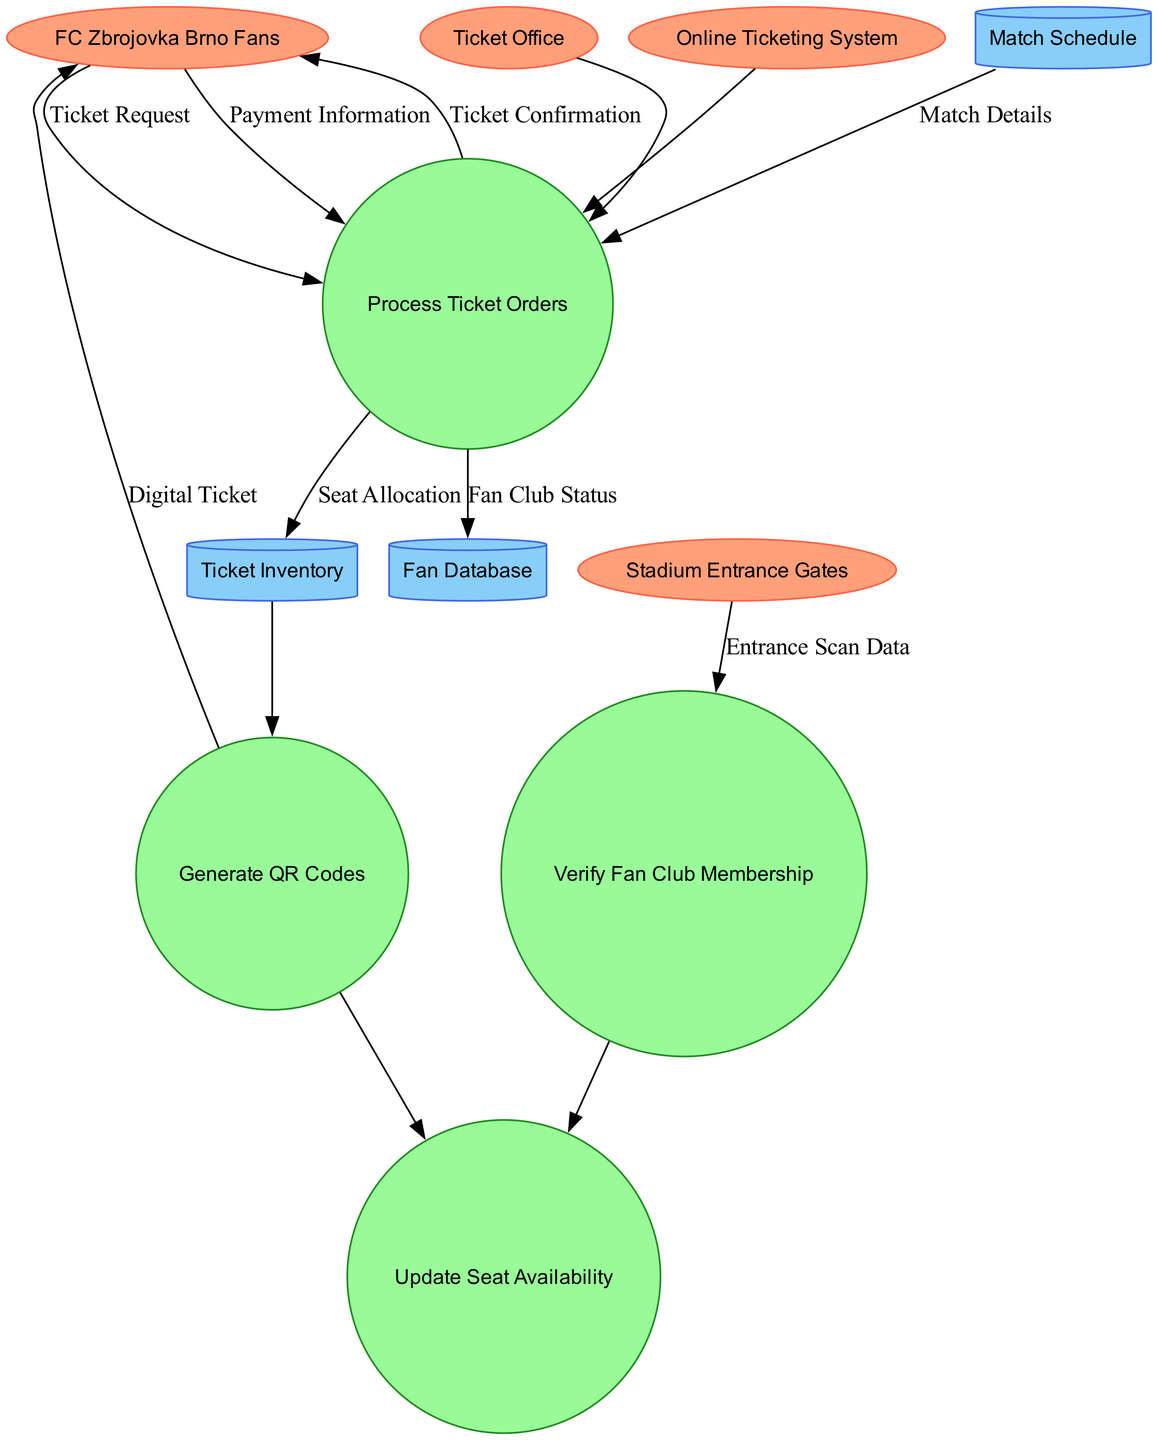What are the external entities present in the diagram? The external entities listed in the diagram are FC Zbrojovka Brno Fans, Ticket Office, Online Ticketing System, and Stadium Entrance Gates. These entities interact with the processes in the diagram.
Answer: FC Zbrojovka Brno Fans, Ticket Office, Online Ticketing System, Stadium Entrance Gates Which process generates QR Codes? The diagram indicates that the process responsible for generating QR Codes is labeled "Generate QR Codes." This can be directly identified in the processes section of the diagram.
Answer: Generate QR Codes How many data stores are depicted in the diagram? There are three data stores shown in the diagram, which are the Fan Database, Ticket Inventory, and Match Schedule. A count of the listed data stores confirms this.
Answer: 3 What type of data flow is established between FC Zbrojovka Brno Fans and the Match Schedule? According to the diagram, there is no direct data flow established between FC Zbrojovka Brno Fans and the Match Schedule. The flows indicate connections to processes rather than directly to this data store.
Answer: None What is the relationship between the "Process Ticket Orders" and the "Ticket Inventory"? The relationship is indicated by a data flow where "Seat Allocation" is directed from the "Process Ticket Orders" process to the "Ticket Inventory" data store. This shows that when ticket orders are processed, the seat availability gets updated in the inventory.
Answer: Seat Allocation Which external entity receives the "Digital Ticket"? The "Digital Ticket" is sent to the FC Zbrojovka Brno Fans after they complete their ticket order in the system. This is illustrated by the flow connections in the diagram.
Answer: FC Zbrojovka Brno Fans What triggers the "Verify Fan Club Membership" process? The trigger for this process is the "Entrance Scan Data" that is received from the Stadium Entrance Gates, which ensures that only valid members can enter based on their membership status.
Answer: Entrance Scan Data What is the outcome of the "Payment Information" flow? The outcome of the "Payment Information" flow is that it is handled in the "Process Ticket Orders," after which the fan receives a "Ticket Confirmation" indicating that their order has been successfully processed.
Answer: Ticket Confirmation 